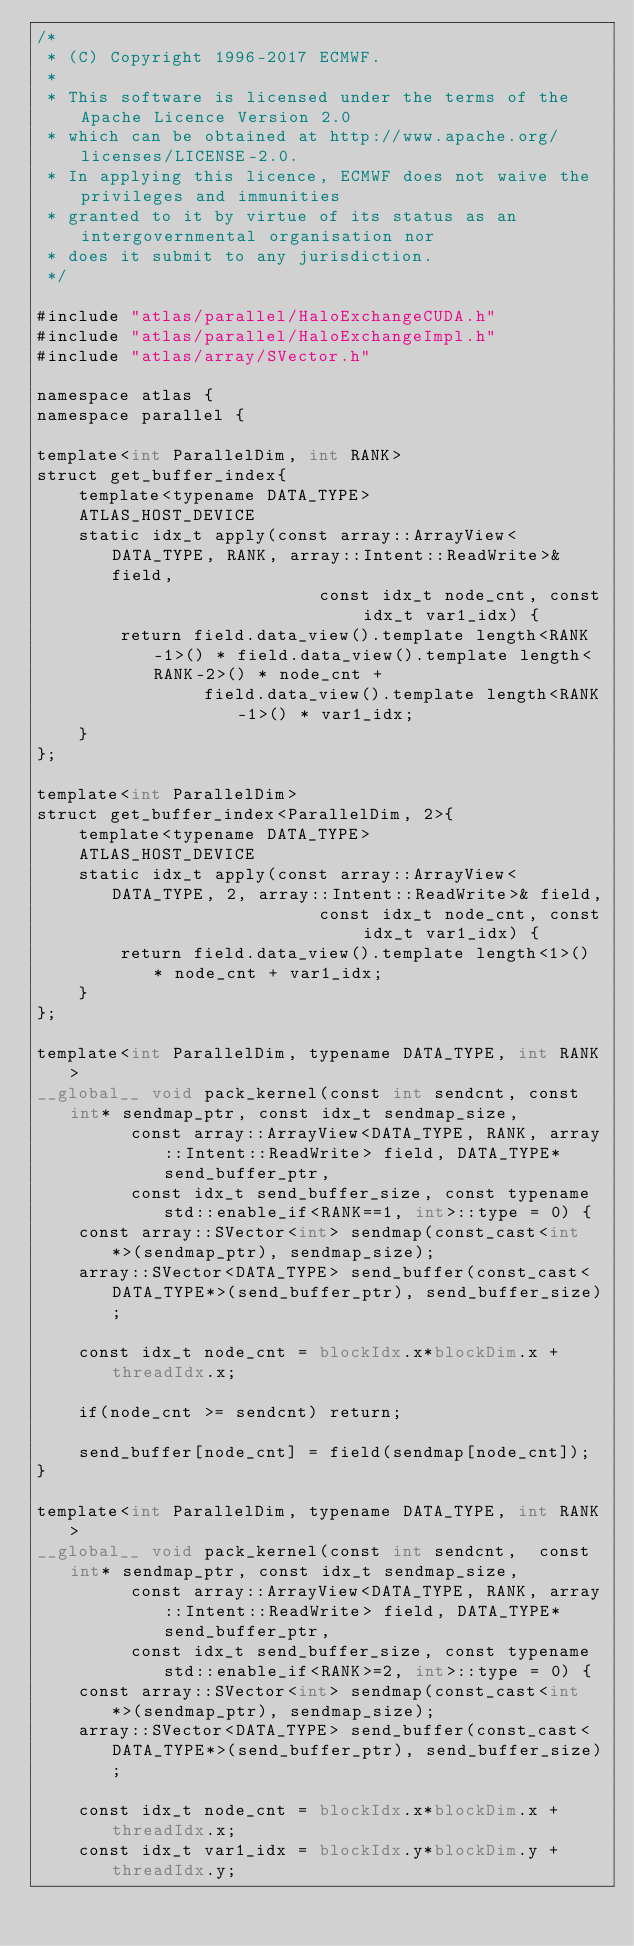Convert code to text. <code><loc_0><loc_0><loc_500><loc_500><_Cuda_>/*
 * (C) Copyright 1996-2017 ECMWF.
 *
 * This software is licensed under the terms of the Apache Licence Version 2.0
 * which can be obtained at http://www.apache.org/licenses/LICENSE-2.0.
 * In applying this licence, ECMWF does not waive the privileges and immunities
 * granted to it by virtue of its status as an intergovernmental organisation nor
 * does it submit to any jurisdiction.
 */

#include "atlas/parallel/HaloExchangeCUDA.h"
#include "atlas/parallel/HaloExchangeImpl.h"
#include "atlas/array/SVector.h"

namespace atlas {
namespace parallel {

template<int ParallelDim, int RANK>
struct get_buffer_index{
    template<typename DATA_TYPE>
    ATLAS_HOST_DEVICE
    static idx_t apply(const array::ArrayView<DATA_TYPE, RANK, array::Intent::ReadWrite>& field,
                           const idx_t node_cnt, const idx_t var1_idx) {
        return field.data_view().template length<RANK-1>() * field.data_view().template length<RANK-2>() * node_cnt +
                field.data_view().template length<RANK-1>() * var1_idx;
    }
};

template<int ParallelDim>
struct get_buffer_index<ParallelDim, 2>{
    template<typename DATA_TYPE>
    ATLAS_HOST_DEVICE
    static idx_t apply(const array::ArrayView<DATA_TYPE, 2, array::Intent::ReadWrite>& field,
                           const idx_t node_cnt, const idx_t var1_idx) {
        return field.data_view().template length<1>() * node_cnt + var1_idx;
    }
};

template<int ParallelDim, typename DATA_TYPE, int RANK>
__global__ void pack_kernel(const int sendcnt, const int* sendmap_ptr, const idx_t sendmap_size,
         const array::ArrayView<DATA_TYPE, RANK, array::Intent::ReadWrite> field, DATA_TYPE* send_buffer_ptr,
         const idx_t send_buffer_size, const typename std::enable_if<RANK==1, int>::type = 0) {
    const array::SVector<int> sendmap(const_cast<int*>(sendmap_ptr), sendmap_size);
    array::SVector<DATA_TYPE> send_buffer(const_cast<DATA_TYPE*>(send_buffer_ptr), send_buffer_size);

    const idx_t node_cnt = blockIdx.x*blockDim.x + threadIdx.x;

    if(node_cnt >= sendcnt) return;

    send_buffer[node_cnt] = field(sendmap[node_cnt]);
}

template<int ParallelDim, typename DATA_TYPE, int RANK>
__global__ void pack_kernel(const int sendcnt,  const int* sendmap_ptr, const idx_t sendmap_size,
         const array::ArrayView<DATA_TYPE, RANK, array::Intent::ReadWrite> field, DATA_TYPE* send_buffer_ptr,
         const idx_t send_buffer_size, const typename std::enable_if<RANK>=2, int>::type = 0) {
    const array::SVector<int> sendmap(const_cast<int*>(sendmap_ptr), sendmap_size);
    array::SVector<DATA_TYPE> send_buffer(const_cast<DATA_TYPE*>(send_buffer_ptr), send_buffer_size);

    const idx_t node_cnt = blockIdx.x*blockDim.x + threadIdx.x;
    const idx_t var1_idx = blockIdx.y*blockDim.y + threadIdx.y;
</code> 